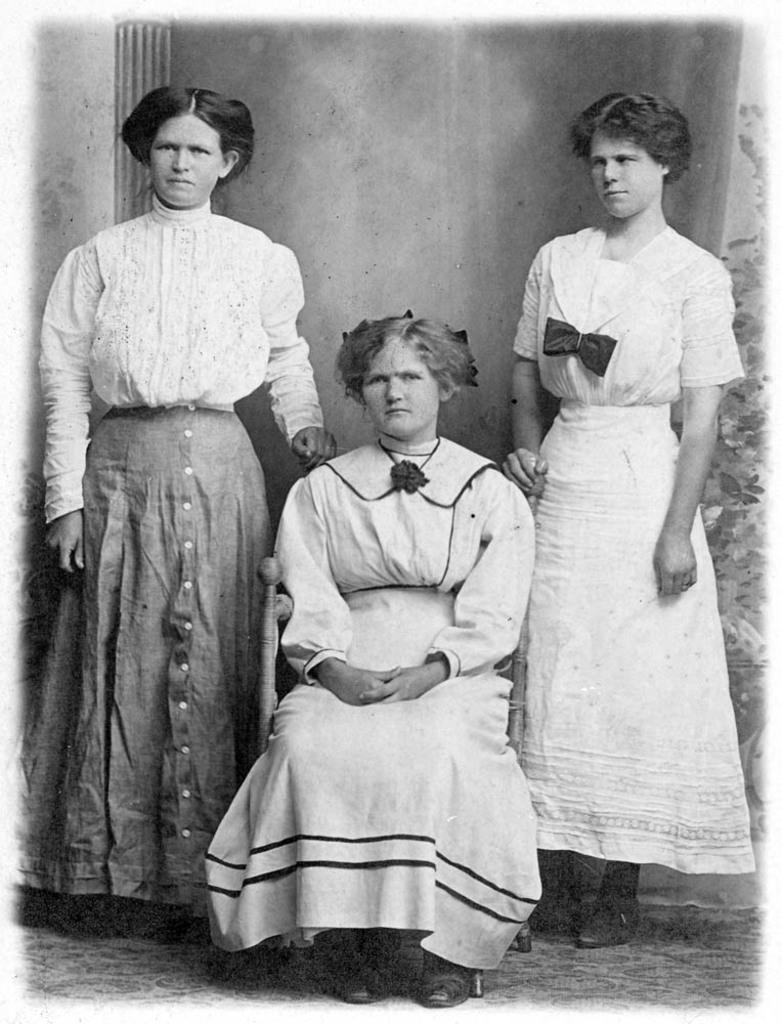What is the color scheme of the image? The image is black and white. How many people are present in the image? There are two persons standing and one person sitting on a chair in the image. What can be seen in the background of the image? There is a wall in the background of the image. What time of day does the wave crash on the shore in the image? There is no wave or shore present in the image, as it is a black and white image featuring two standing persons and one sitting person with a wall in the background. 